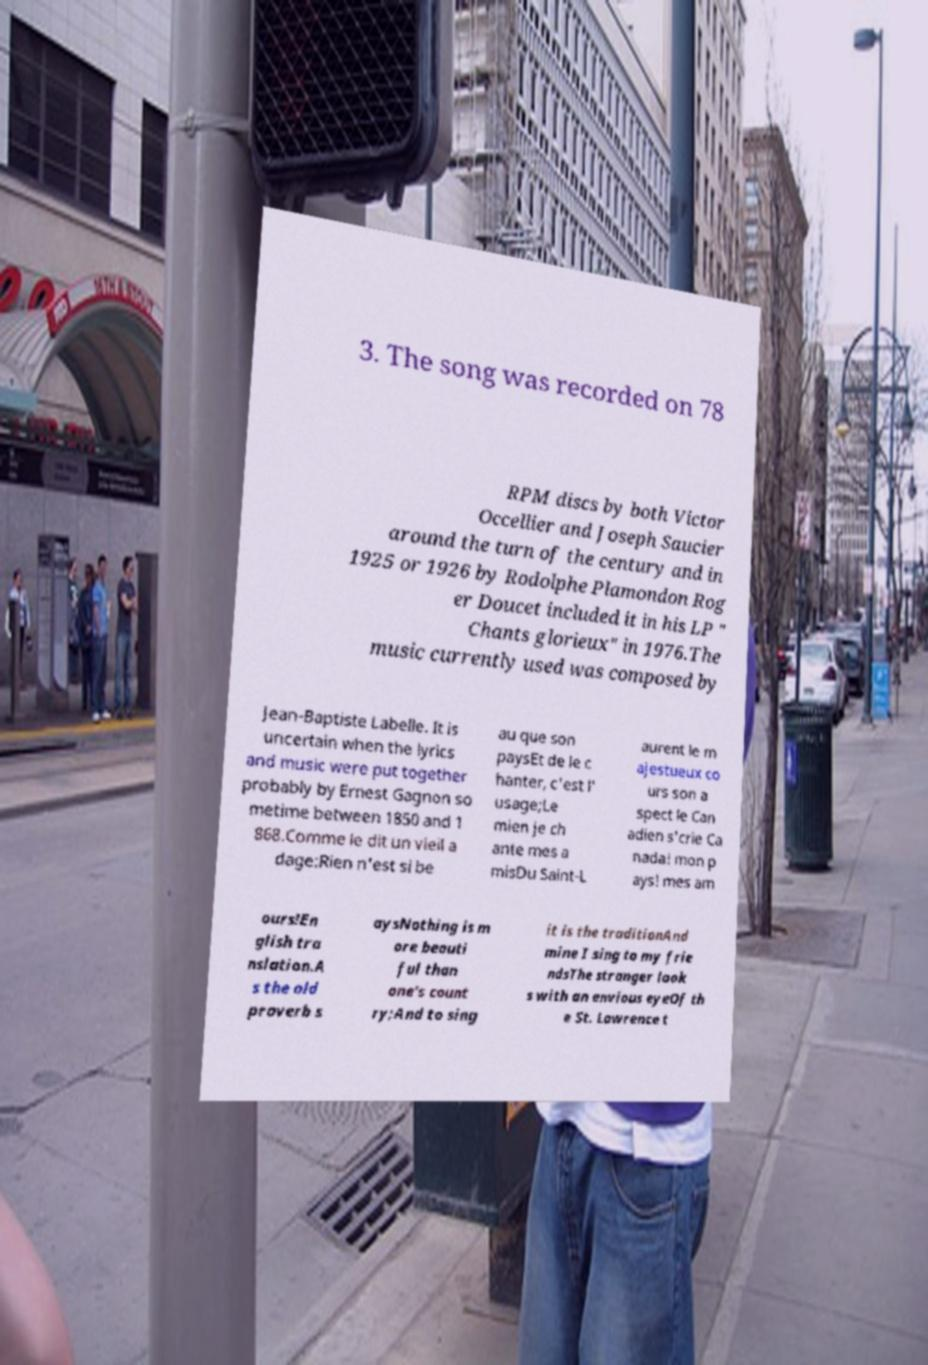What messages or text are displayed in this image? I need them in a readable, typed format. 3. The song was recorded on 78 RPM discs by both Victor Occellier and Joseph Saucier around the turn of the century and in 1925 or 1926 by Rodolphe Plamondon Rog er Doucet included it in his LP " Chants glorieux" in 1976.The music currently used was composed by Jean-Baptiste Labelle. It is uncertain when the lyrics and music were put together probably by Ernest Gagnon so metime between 1850 and 1 868.Comme le dit un vieil a dage:Rien n'est si be au que son paysEt de le c hanter, c'est l' usage;Le mien je ch ante mes a misDu Saint-L aurent le m ajestueux co urs son a spect le Can adien s'crie Ca nada! mon p ays! mes am ours!En glish tra nslation.A s the old proverb s aysNothing is m ore beauti ful than one's count ry;And to sing it is the traditionAnd mine I sing to my frie ndsThe stranger look s with an envious eyeOf th e St. Lawrence t 